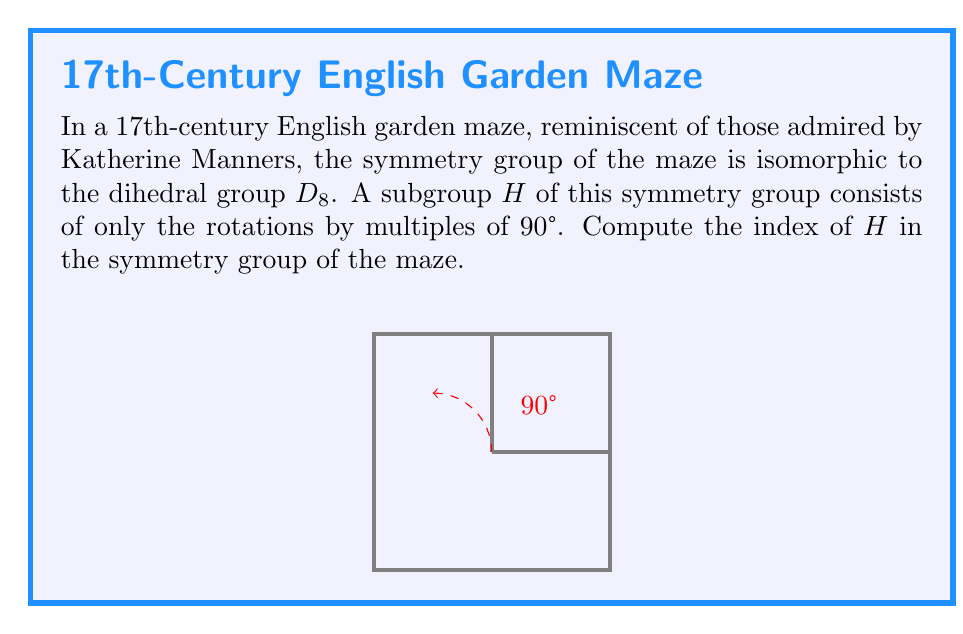Could you help me with this problem? Let's approach this step-by-step:

1) First, recall that the index of a subgroup $H$ in a group $G$ is defined as:

   $[G:H] = \frac{|G|}{|H|}$

   where $|G|$ and $|H|$ are the orders of $G$ and $H$ respectively.

2) The symmetry group of the maze is isomorphic to $D_8$, the dihedral group of order 8. Therefore, $|G| = 8$.

3) The dihedral group $D_8$ consists of:
   - 4 rotations (0°, 90°, 180°, 270°)
   - 4 reflections (2 diagonal and 2 axial)

4) The subgroup $H$ consists only of rotations by multiples of 90°. These are:
   - Rotation by 0° (identity)
   - Rotation by 90°
   - Rotation by 180°
   - Rotation by 270°

5) Therefore, $|H| = 4$

6) Now we can calculate the index:

   $$[G:H] = \frac{|G|}{|H|} = \frac{8}{4} = 2$$

Thus, the index of $H$ in the symmetry group of the maze is 2.
Answer: 2 